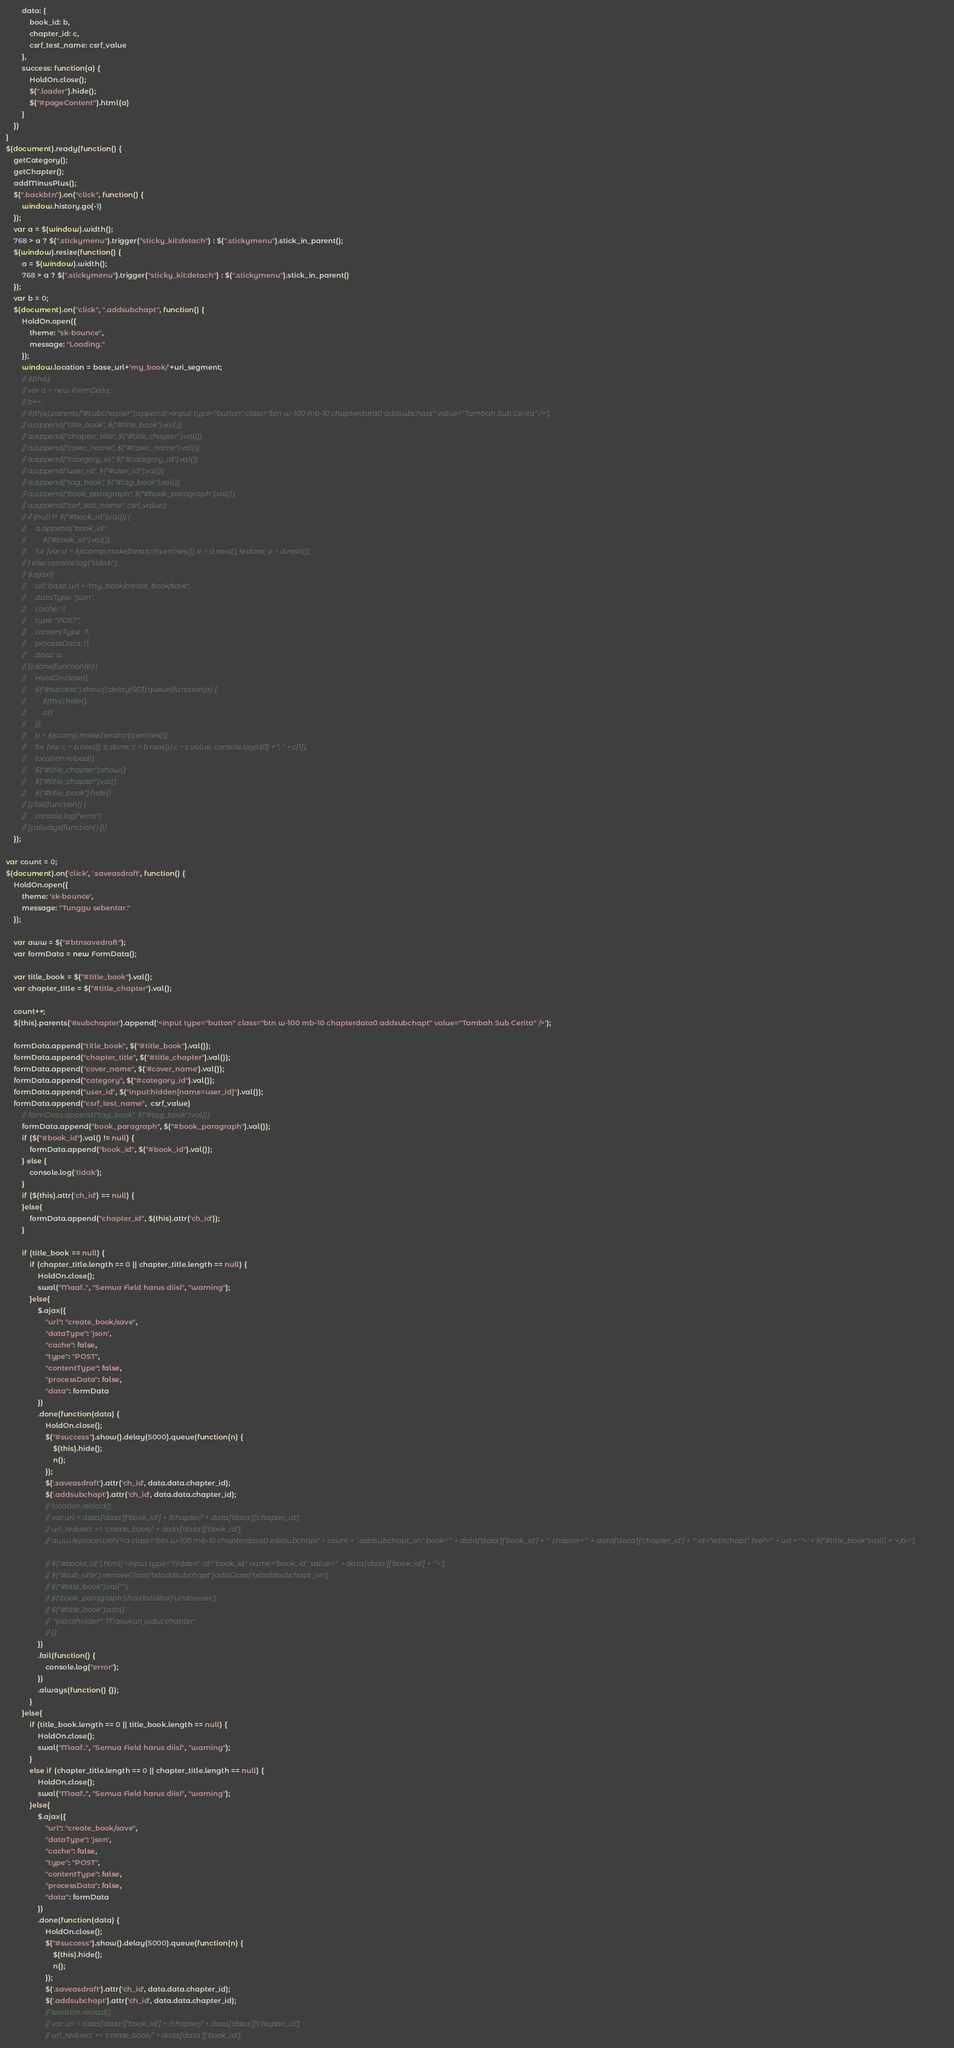Convert code to text. <code><loc_0><loc_0><loc_500><loc_500><_JavaScript_>        data: {
            book_id: b,
            chapter_id: c,
            csrf_test_name: csrf_value
        },
        success: function(a) {
            HoldOn.close();
            $(".loader").hide();
            $("#pageContent").html(a)
        }
    })
}
$(document).ready(function() {
    getCategory();
    getChapter();
    addMinusPlus();
    $(".backbtn").on("click", function() {
        window.history.go(-1)
    });
    var a = $(window).width();
    768 > a ? $(".stickymenu").trigger("sticky_kit:detach") : $(".stickymenu").stick_in_parent();
    $(window).resize(function() {
        a = $(window).width();
        768 > a ? $(".stickymenu").trigger("sticky_kit:detach") : $(".stickymenu").stick_in_parent()
    });
    var b = 0;
    $(document).on("click", ".addsubchapt", function() {
        HoldOn.open({
            theme: "sk-bounce",
            message: "Loading."
        });
        window.location = base_url+'my_book/'+uri_segment;
        // $(this);
        // var a = new FormData;
        // b++;
        // $(this).parents("#subchapter").append('<input type="button" class="btn w-100 mb-10 chapterdata0 addsubchapt" value="Tambah Sub Cerita" />');
        // a.append("title_book", $("#title_book").val());
        // a.append("chapter_title", $("#title_chapter").val());
        // a.append("cover_name", $("#cover_name").val());
        // a.append("category_id", $("#category_id").val());
        // a.append("user_id", $("#user_id").val());
        // a.append("tag_book", $("#tag_book").val());
        // a.append("book_paragraph", $("#book_paragraph").val());
        // a.append("csrf_test_name", csrf_value);
        // if (null != $("#book_id").val()) {
        //     a.append("book_id",
        //         $("#book_id").val());
        //     for (var d = $jscomp.makeIterator(a.entries()), e = d.next(); !e.done; e = d.next());
        // } else console.log("tidak");
        // $.ajax({
        //     url: base_url + "my_book/create_book/save",
        //     dataType: "json",
        //     cache: !1,
        //     type: "POST",
        //     contentType: !1,
        //     processData: !1,
        //     data: a
        // }).done(function(b) {
        //     HoldOn.close();
        //     $("#success").show().delay(5E3).queue(function(a) {
        //         $(this).hide();
        //         a()
        //     });
        //     b = $jscomp.makeIterator(a.entries());
        //     for (var c = b.next(); !c.done; c = b.next()) c = c.value, console.log(c[0] + ", " + c[1]);
        //     location.reload();
        //     $("#title_chapter").show();
        //     $("#title_chapter").val();
        //     $("#title_book").hide()
        // }).fail(function() {
        //     console.log("error")
        // }).always(function() {})
    });

var count = 0;
$(document).on('click', '.saveasdraft', function() {
    HoldOn.open({
        theme: 'sk-bounce',
        message: "Tunggu sebentar."
    });

    var aww = $("#btnsavedraft");
    var formData = new FormData();

    var title_book = $("#title_book").val();
    var chapter_title = $("#title_chapter").val();

    count++;
    $(this).parents('#subchapter').append('<input type="button" class="btn w-100 mb-10 chapterdata0 addsubchapt" value="Tambah Sub Cerita" />');

    formData.append("title_book", $("#title_book").val());
    formData.append("chapter_title", $("#title_chapter").val());
    formData.append("cover_name", $('#cover_name').val());
    formData.append("category", $("#category_id").val());
    formData.append("user_id", $("input:hidden[name=user_id]").val());
    formData.append("csrf_test_name",  csrf_value)
        // formData.append("tag_book", $("#tag_book").val());
        formData.append("book_paragraph", $("#book_paragraph").val());
        if ($("#book_id").val() != null) {
            formData.append("book_id", $("#book_id").val());
        } else {
            console.log('tidak');
        }
        if ($(this).attr('ch_id') == null) {
        }else{
            formData.append("chapter_id", $(this).attr('ch_id'));
        }

        if (title_book == null) {
            if (chapter_title.length == 0 || chapter_title.length == null) {
                HoldOn.close();
                swal("Maaf..", "Semua Field harus diisi", "warning");
            }else{
                $.ajax({
                    "url": "create_book/save",
                    "dataType": 'json',
                    "cache": false,
                    "type": "POST",
                    "contentType": false,
                    "processData": false,
                    "data": formData
                })
                .done(function(data) {
                    HoldOn.close();
                    $("#success").show().delay(5000).queue(function(n) {
                        $(this).hide();
                        n();
                    });
                    $('.saveasdraft').attr('ch_id', data.data.chapter_id);
                    $('.addsubchapt').attr('ch_id', data.data.chapter_id);
                    // location.reload();
                    // var url = data['data']['book_id'] + '/chapter/' + data['data']['chapter_id'];
                    // url_redirect += 'create_book/' + data['data']['book_id'];
                    // aww.replaceWith('<a class="btn w-100 mb-10 chapterdata0 editsubchapt' + count + ' addsubchapt_on" book="' + data['data']['book_id'] + '" chapter="' + data['data']['chapter_id'] + '" id="editchapt" href="' + url + '">' + $("#title_book").val() + '</a>');

                    // $("#books_id").html('<input type="hidden" id="book_id" name="book_id" value="' + data['data']['book_id'] + '">');
                    // $("#sub_title").removeClass('txtaddsubchapt').addClass('txtaddsubchapt_on');
                    // $("#title_book").val("");
                    // $('.book_paragraph').froalaEditor('undo.reset');
                    // $("#title_book").attr({
                    //  "placeholder": 'Masukan judul chapter'
                    // });
                })
                .fail(function() {
                    console.log("error");
                })
                .always(function() {});
            }
        }else{
            if (title_book.length == 0 || title_book.length == null) {
                HoldOn.close();
                swal("Maaf..", "Semua Field harus diisi", "warning");
            }
            else if (chapter_title.length == 0 || chapter_title.length == null) {
                HoldOn.close();
                swal("Maaf..", "Semua Field harus diisi", "warning");
            }else{
                $.ajax({
                    "url": "create_book/save",
                    "dataType": 'json',
                    "cache": false,
                    "type": "POST",
                    "contentType": false,
                    "processData": false,
                    "data": formData
                })
                .done(function(data) {
                    HoldOn.close();
                    $("#success").show().delay(5000).queue(function(n) {
                        $(this).hide();
                        n();
                    });
                    $('.saveasdraft').attr('ch_id', data.data.chapter_id);
                    $('.addsubchapt').attr('ch_id', data.data.chapter_id);
                    // location.reload();
                    // var url = data['data']['book_id'] + '/chapter/' + data['data']['chapter_id'];
                    // url_redirect += 'create_book/' + data['data']['book_id'];</code> 